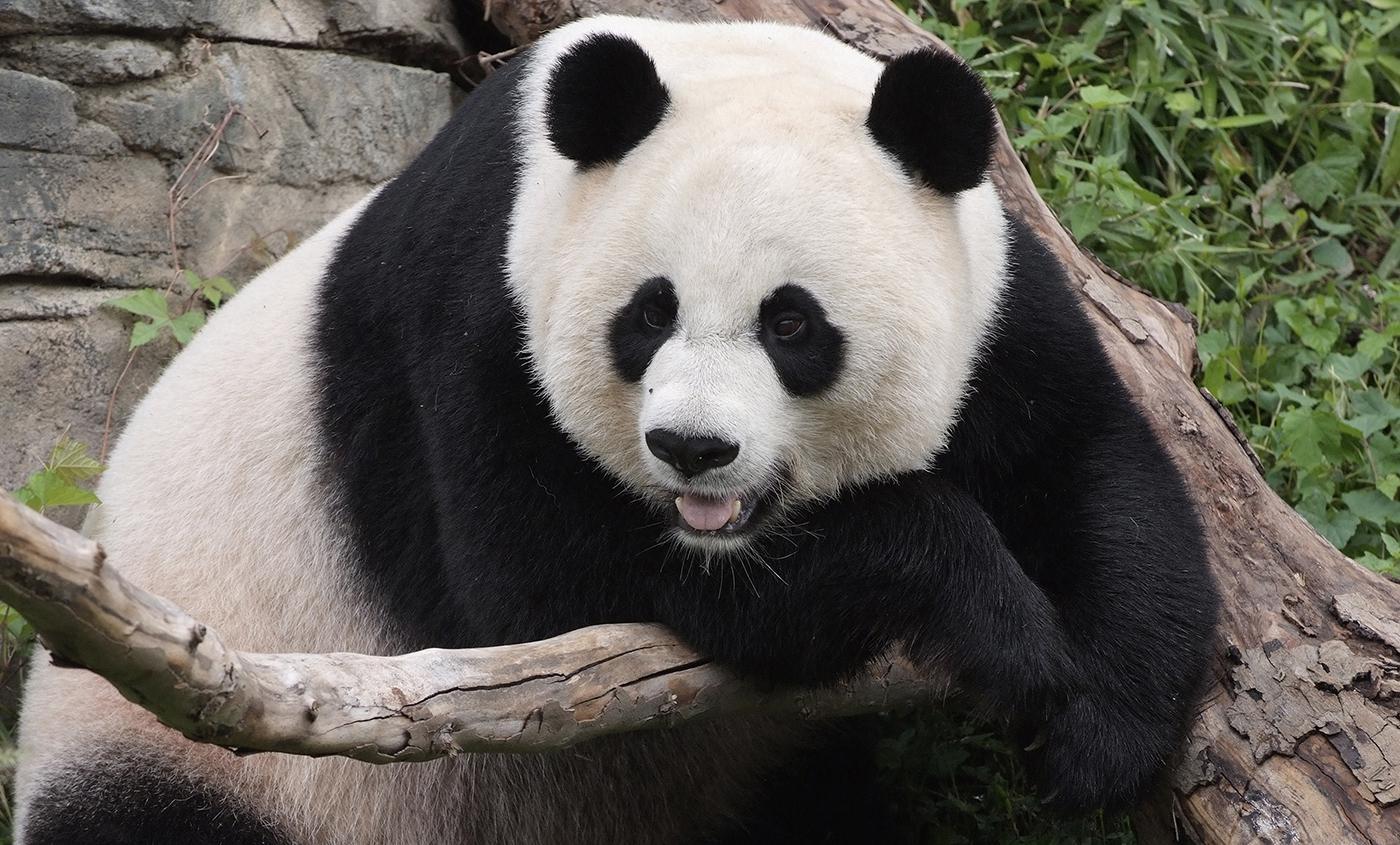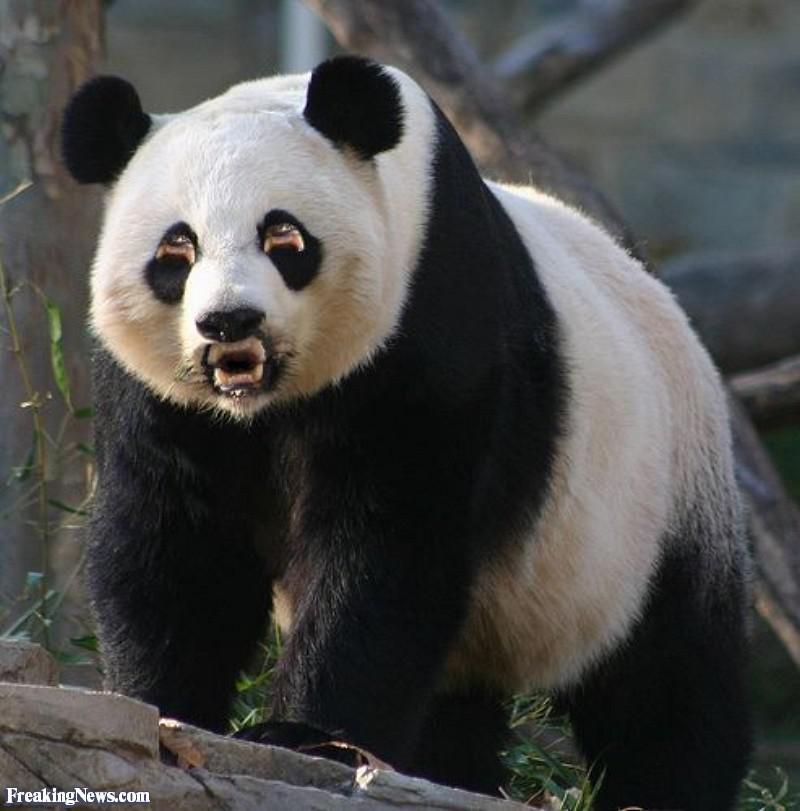The first image is the image on the left, the second image is the image on the right. Considering the images on both sides, is "An image includes a panda at least partly on its back on green ground." valid? Answer yes or no. No. 